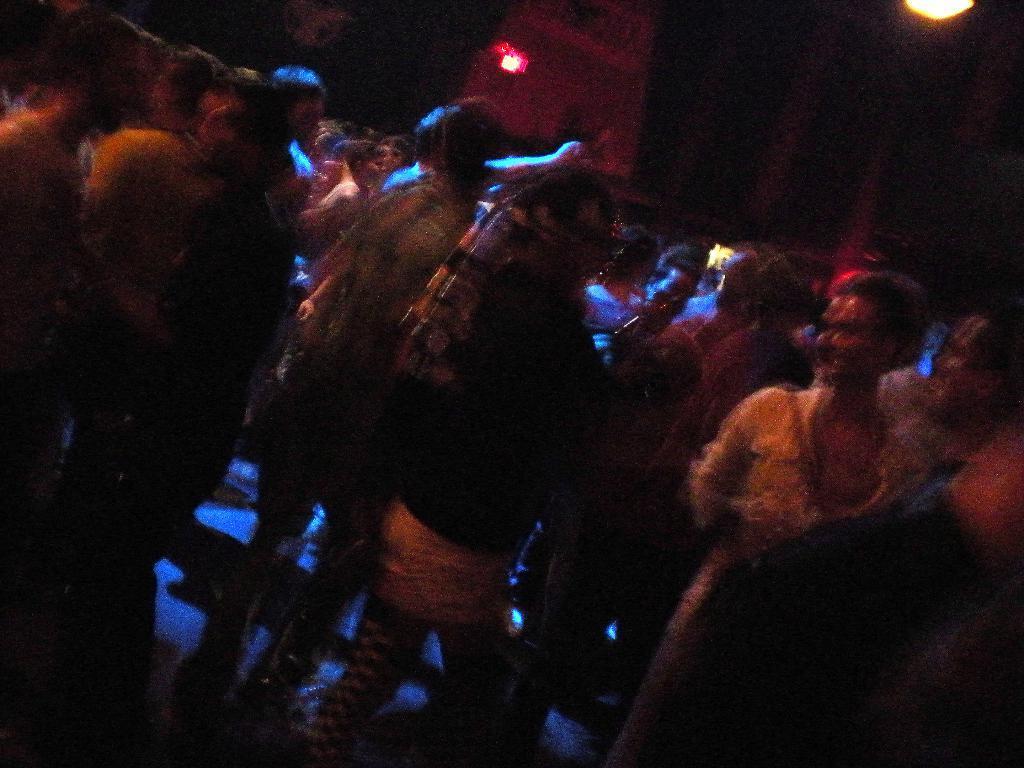Can you describe this image briefly? In the picture we can see some people are standing and some are dancing and in the background we can see a light which is red in color and in the middle of the people we can see blue color light focus. 